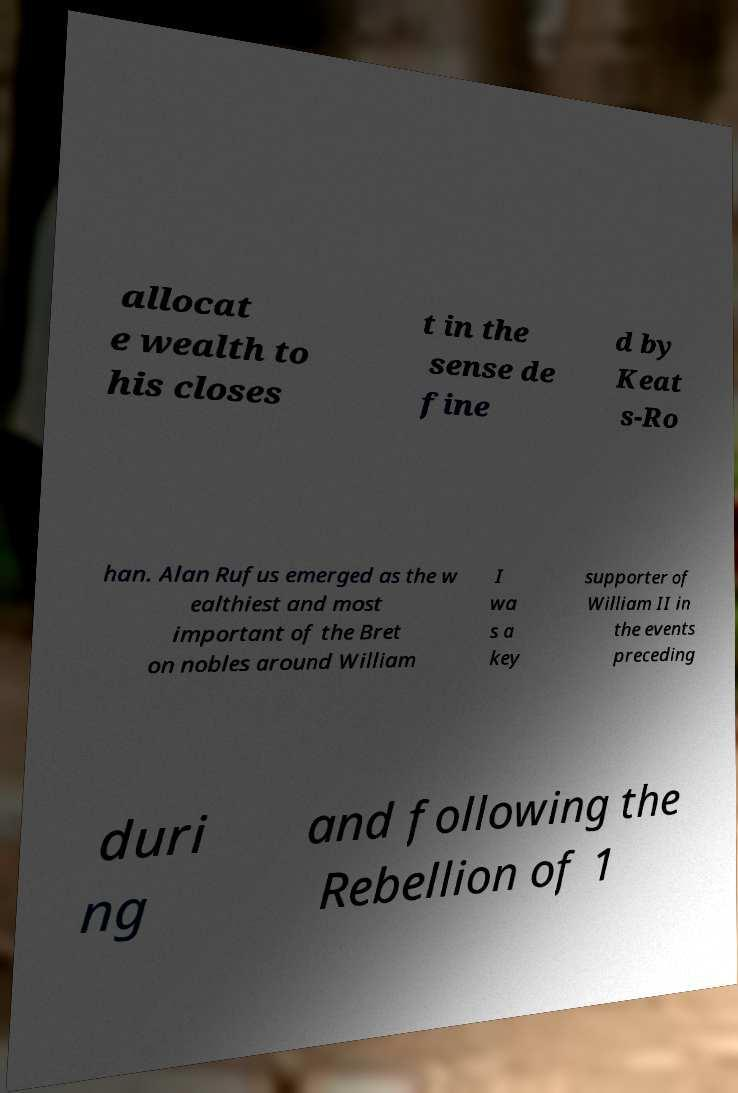Could you assist in decoding the text presented in this image and type it out clearly? allocat e wealth to his closes t in the sense de fine d by Keat s-Ro han. Alan Rufus emerged as the w ealthiest and most important of the Bret on nobles around William I wa s a key supporter of William II in the events preceding duri ng and following the Rebellion of 1 